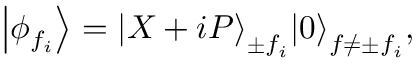<formula> <loc_0><loc_0><loc_500><loc_500>\left | { { \phi } _ { { { f } _ { i } } } } \right \rangle = { { \left | X + i P \right \rangle } _ { \pm { { f } _ { i } } } } { { \left | 0 \right \rangle } _ { f \ne \pm { { f } _ { i } } } } ,</formula> 